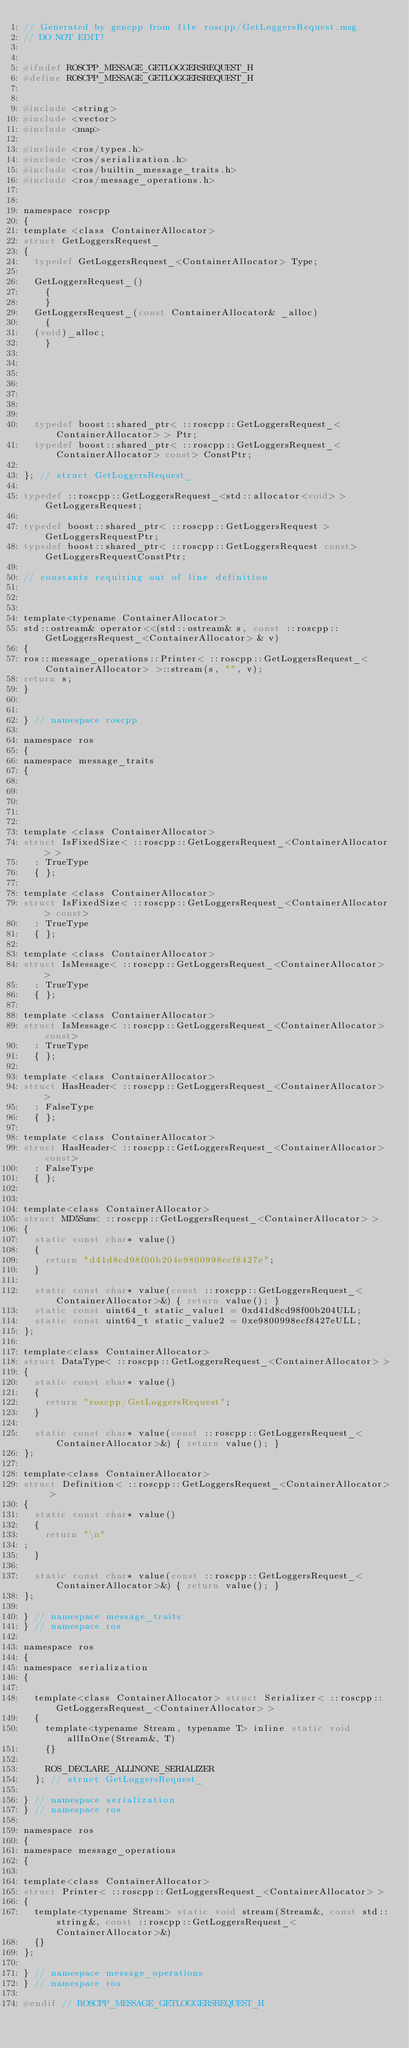<code> <loc_0><loc_0><loc_500><loc_500><_C_>// Generated by gencpp from file roscpp/GetLoggersRequest.msg
// DO NOT EDIT!


#ifndef ROSCPP_MESSAGE_GETLOGGERSREQUEST_H
#define ROSCPP_MESSAGE_GETLOGGERSREQUEST_H


#include <string>
#include <vector>
#include <map>

#include <ros/types.h>
#include <ros/serialization.h>
#include <ros/builtin_message_traits.h>
#include <ros/message_operations.h>


namespace roscpp
{
template <class ContainerAllocator>
struct GetLoggersRequest_
{
  typedef GetLoggersRequest_<ContainerAllocator> Type;

  GetLoggersRequest_()
    {
    }
  GetLoggersRequest_(const ContainerAllocator& _alloc)
    {
  (void)_alloc;
    }







  typedef boost::shared_ptr< ::roscpp::GetLoggersRequest_<ContainerAllocator> > Ptr;
  typedef boost::shared_ptr< ::roscpp::GetLoggersRequest_<ContainerAllocator> const> ConstPtr;

}; // struct GetLoggersRequest_

typedef ::roscpp::GetLoggersRequest_<std::allocator<void> > GetLoggersRequest;

typedef boost::shared_ptr< ::roscpp::GetLoggersRequest > GetLoggersRequestPtr;
typedef boost::shared_ptr< ::roscpp::GetLoggersRequest const> GetLoggersRequestConstPtr;

// constants requiring out of line definition



template<typename ContainerAllocator>
std::ostream& operator<<(std::ostream& s, const ::roscpp::GetLoggersRequest_<ContainerAllocator> & v)
{
ros::message_operations::Printer< ::roscpp::GetLoggersRequest_<ContainerAllocator> >::stream(s, "", v);
return s;
}


} // namespace roscpp

namespace ros
{
namespace message_traits
{





template <class ContainerAllocator>
struct IsFixedSize< ::roscpp::GetLoggersRequest_<ContainerAllocator> >
  : TrueType
  { };

template <class ContainerAllocator>
struct IsFixedSize< ::roscpp::GetLoggersRequest_<ContainerAllocator> const>
  : TrueType
  { };

template <class ContainerAllocator>
struct IsMessage< ::roscpp::GetLoggersRequest_<ContainerAllocator> >
  : TrueType
  { };

template <class ContainerAllocator>
struct IsMessage< ::roscpp::GetLoggersRequest_<ContainerAllocator> const>
  : TrueType
  { };

template <class ContainerAllocator>
struct HasHeader< ::roscpp::GetLoggersRequest_<ContainerAllocator> >
  : FalseType
  { };

template <class ContainerAllocator>
struct HasHeader< ::roscpp::GetLoggersRequest_<ContainerAllocator> const>
  : FalseType
  { };


template<class ContainerAllocator>
struct MD5Sum< ::roscpp::GetLoggersRequest_<ContainerAllocator> >
{
  static const char* value()
  {
    return "d41d8cd98f00b204e9800998ecf8427e";
  }

  static const char* value(const ::roscpp::GetLoggersRequest_<ContainerAllocator>&) { return value(); }
  static const uint64_t static_value1 = 0xd41d8cd98f00b204ULL;
  static const uint64_t static_value2 = 0xe9800998ecf8427eULL;
};

template<class ContainerAllocator>
struct DataType< ::roscpp::GetLoggersRequest_<ContainerAllocator> >
{
  static const char* value()
  {
    return "roscpp/GetLoggersRequest";
  }

  static const char* value(const ::roscpp::GetLoggersRequest_<ContainerAllocator>&) { return value(); }
};

template<class ContainerAllocator>
struct Definition< ::roscpp::GetLoggersRequest_<ContainerAllocator> >
{
  static const char* value()
  {
    return "\n"
;
  }

  static const char* value(const ::roscpp::GetLoggersRequest_<ContainerAllocator>&) { return value(); }
};

} // namespace message_traits
} // namespace ros

namespace ros
{
namespace serialization
{

  template<class ContainerAllocator> struct Serializer< ::roscpp::GetLoggersRequest_<ContainerAllocator> >
  {
    template<typename Stream, typename T> inline static void allInOne(Stream&, T)
    {}

    ROS_DECLARE_ALLINONE_SERIALIZER
  }; // struct GetLoggersRequest_

} // namespace serialization
} // namespace ros

namespace ros
{
namespace message_operations
{

template<class ContainerAllocator>
struct Printer< ::roscpp::GetLoggersRequest_<ContainerAllocator> >
{
  template<typename Stream> static void stream(Stream&, const std::string&, const ::roscpp::GetLoggersRequest_<ContainerAllocator>&)
  {}
};

} // namespace message_operations
} // namespace ros

#endif // ROSCPP_MESSAGE_GETLOGGERSREQUEST_H
</code> 